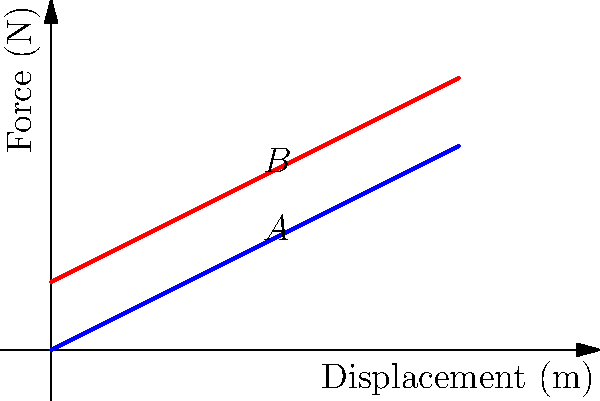A spring-mass system exhibits two different force-displacement curves ($F_1$ and $F_2$) as shown in the graph. The difference between the forces at point A and B is 1 N. If the spring constant for $F_1$ is 0.5 N/m, what is the work done in moving the mass from the equilibrium position to the point where the displacement is 3 m along curve $F_2$? Let's approach this step-by-step:

1) First, we need to understand what the graph represents:
   - $F_1$ is the original force-displacement curve with spring constant $k_1 = 0.5$ N/m
   - $F_2$ is a parallel curve shifted upwards by 1 N

2) The equation for $F_1$ is:
   $F_1 = k_1x = 0.5x$

3) The equation for $F_2$ is:
   $F_2 = k_1x + 1 = 0.5x + 1$

4) The work done is the area under the force-displacement curve. For $F_2$, this is:

   $W = \int_0^3 F_2 dx = \int_0^3 (0.5x + 1) dx$

5) Solving the integral:
   $W = [\frac{1}{2}(0.5x^2) + x]_0^3$
   $W = (\frac{1}{2}(0.5(3^2)) + 3) - (0)$
   $W = (2.25 + 3) - 0 = 5.25$ J

Therefore, the work done is 5.25 Joules.
Answer: 5.25 J 